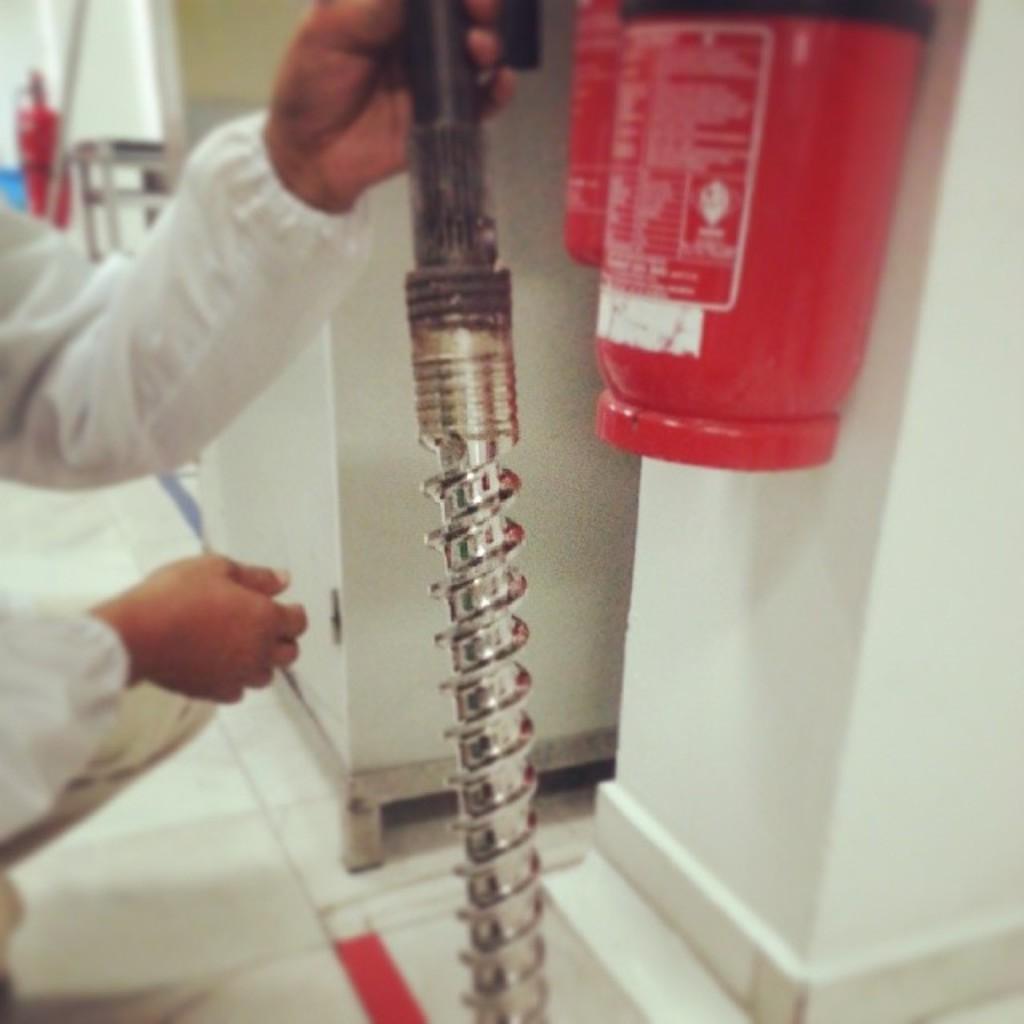Describe this image in one or two sentences. In this image we can see one iron rod hold by a person, two fire extinguishers hanged on the wall and some objects are on the surface. 